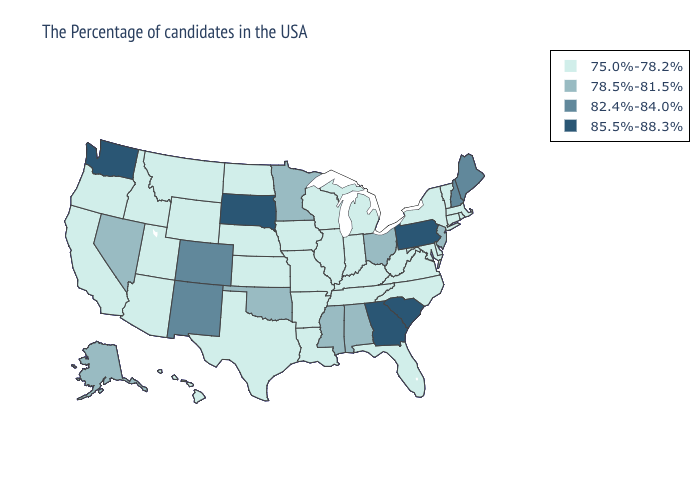Name the states that have a value in the range 85.5%-88.3%?
Concise answer only. Pennsylvania, South Carolina, Georgia, South Dakota, Washington. Does Washington have the highest value in the USA?
Keep it brief. Yes. Does Tennessee have the same value as Nevada?
Answer briefly. No. What is the value of Michigan?
Concise answer only. 75.0%-78.2%. Which states hav the highest value in the MidWest?
Short answer required. South Dakota. Does Idaho have the same value as Minnesota?
Be succinct. No. What is the value of Rhode Island?
Short answer required. 75.0%-78.2%. What is the value of Oregon?
Write a very short answer. 75.0%-78.2%. Name the states that have a value in the range 78.5%-81.5%?
Write a very short answer. New Jersey, Ohio, Alabama, Mississippi, Minnesota, Oklahoma, Nevada, Alaska. What is the value of Idaho?
Give a very brief answer. 75.0%-78.2%. Does South Dakota have the highest value in the MidWest?
Write a very short answer. Yes. What is the value of Oklahoma?
Keep it brief. 78.5%-81.5%. Name the states that have a value in the range 85.5%-88.3%?
Give a very brief answer. Pennsylvania, South Carolina, Georgia, South Dakota, Washington. Does Louisiana have a lower value than New Jersey?
Write a very short answer. Yes. What is the value of California?
Concise answer only. 75.0%-78.2%. 